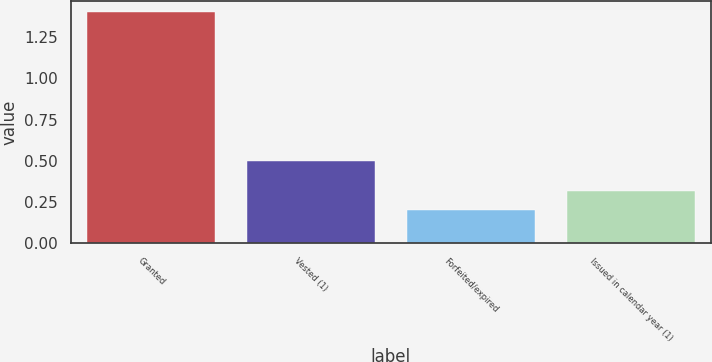Convert chart. <chart><loc_0><loc_0><loc_500><loc_500><bar_chart><fcel>Granted<fcel>Vested (1)<fcel>Forfeited/expired<fcel>Issued in calendar year (1)<nl><fcel>1.4<fcel>0.5<fcel>0.2<fcel>0.32<nl></chart> 